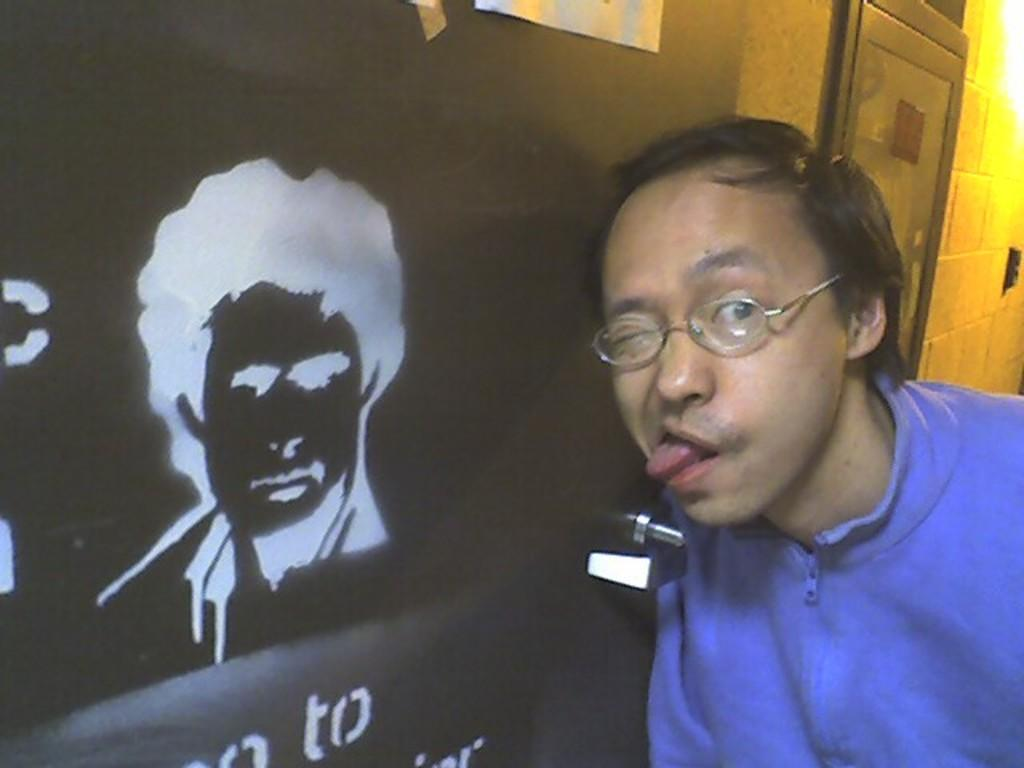What is the main subject of the image? There is a person in the image. Can you describe the object behind the person? There is an object with text behind the person. What type of silk material is being used to paste the verse on the wall in the image? There is no silk material or verse present in the image. 